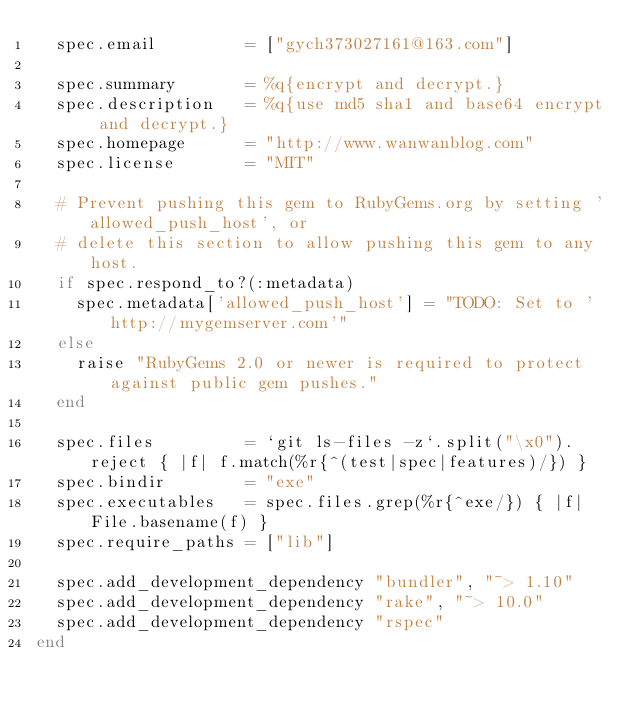<code> <loc_0><loc_0><loc_500><loc_500><_Ruby_>  spec.email         = ["gych373027161@163.com"]

  spec.summary       = %q{encrypt and decrypt.}
  spec.description   = %q{use md5 sha1 and base64 encrypt and decrypt.}
  spec.homepage      = "http://www.wanwanblog.com"
  spec.license       = "MIT"

  # Prevent pushing this gem to RubyGems.org by setting 'allowed_push_host', or
  # delete this section to allow pushing this gem to any host.
  if spec.respond_to?(:metadata)
    spec.metadata['allowed_push_host'] = "TODO: Set to 'http://mygemserver.com'"
  else
    raise "RubyGems 2.0 or newer is required to protect against public gem pushes."
  end

  spec.files         = `git ls-files -z`.split("\x0").reject { |f| f.match(%r{^(test|spec|features)/}) }
  spec.bindir        = "exe"
  spec.executables   = spec.files.grep(%r{^exe/}) { |f| File.basename(f) }
  spec.require_paths = ["lib"]

  spec.add_development_dependency "bundler", "~> 1.10"
  spec.add_development_dependency "rake", "~> 10.0"
  spec.add_development_dependency "rspec"
end
</code> 